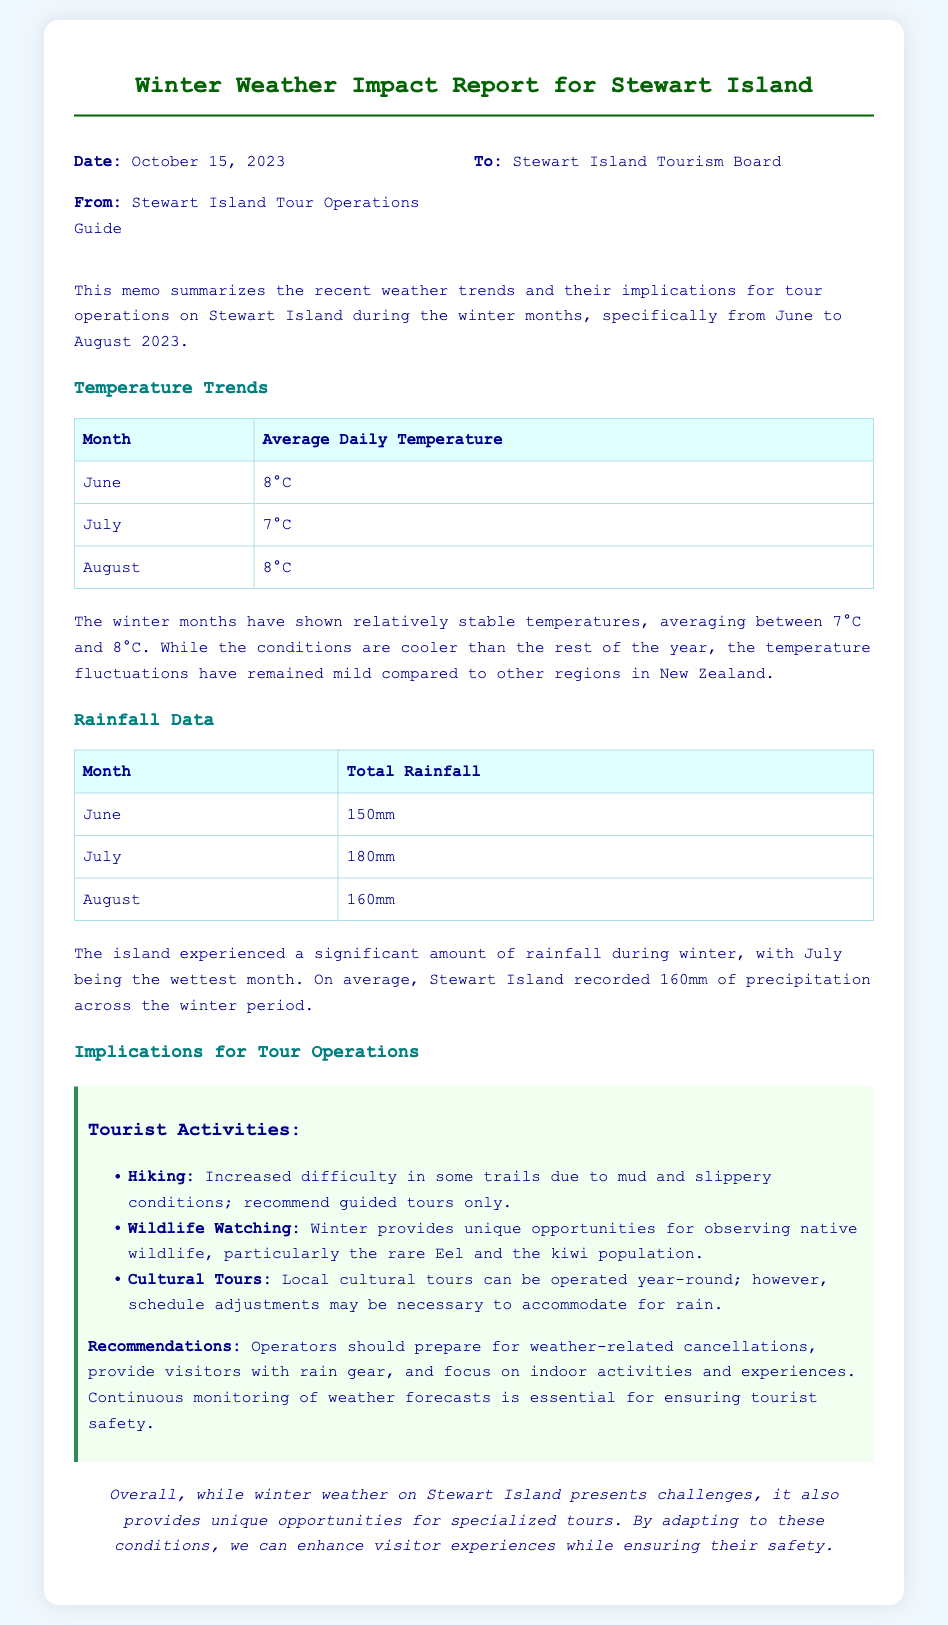What was the average daily temperature in July? The document states that the average daily temperature in July is 7°C.
Answer: 7°C How much rainfall was recorded in August? According to the memo, the total rainfall recorded in August is 160mm.
Answer: 160mm What is the wettest month recorded? The report mentions that July had the highest total rainfall, making it the wettest month.
Answer: July What are the recommended activities for winter? The memo lists hiking, wildlife watching, and cultural tours as activities for winter.
Answer: Hiking, wildlife watching, cultural tours What should operators prepare for regarding weather? The implications section advises operators to prepare for weather-related cancellations.
Answer: Weather-related cancellations How many winter months were analyzed in the report? The report covers three winter months: June, July, and August.
Answer: Three What conclusion does the document suggest about winter weather? The conclusion states that winter weather presents challenges but also unique opportunities for specialized tours.
Answer: Unique opportunities for specialized tours What year is the report focused on? The date indicates that the report summarizes data specifically from the winter of 2023.
Answer: 2023 